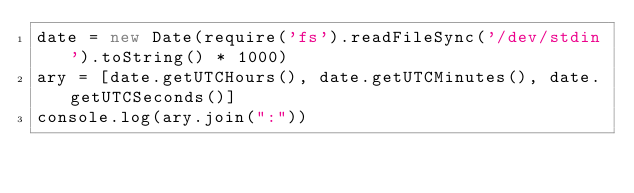Convert code to text. <code><loc_0><loc_0><loc_500><loc_500><_JavaScript_>date = new Date(require('fs').readFileSync('/dev/stdin').toString() * 1000)
ary = [date.getUTCHours(), date.getUTCMinutes(), date.getUTCSeconds()]
console.log(ary.join(":"))</code> 